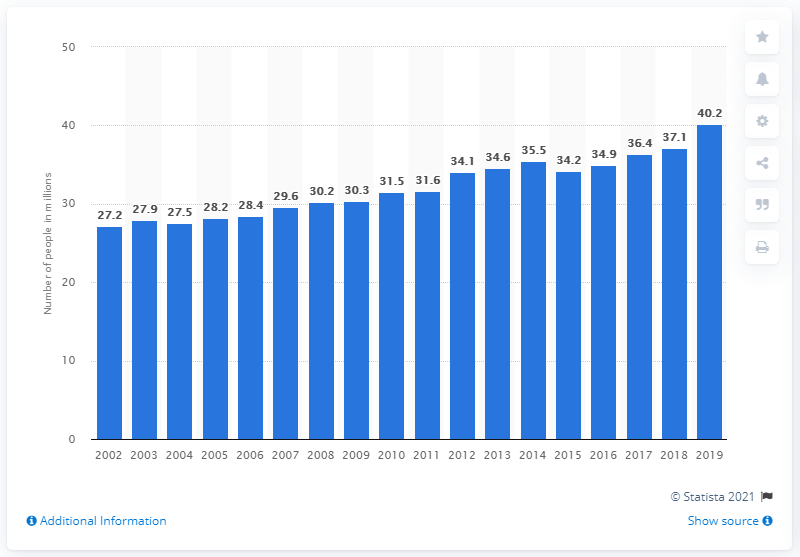Indicate a few pertinent items in this graphic. In 2019, approximately 40.2% of adults in the United States received mental health treatment or counseling. 